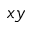<formula> <loc_0><loc_0><loc_500><loc_500>x y</formula> 